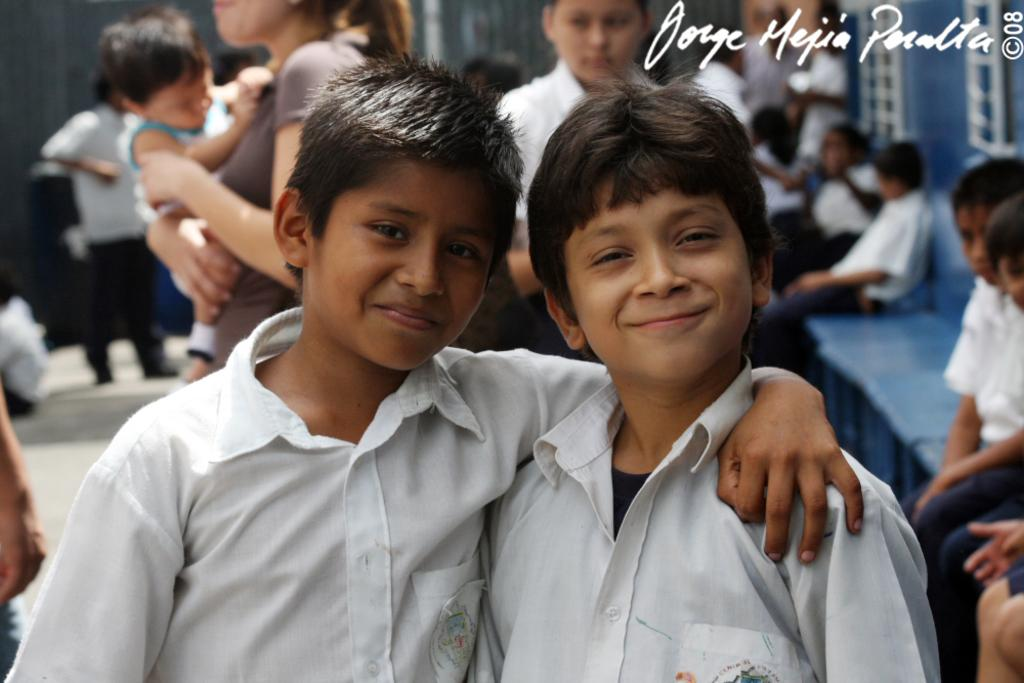How many boys are in the image? There are two boys in the image. What expression do the boys have in the image? The boys are smiling in the image. What can be seen in the background of the image? There is a group of people in the background of the image. What are some of the people in the group doing? Some people in the group are standing, and some are sitting. What type of cannon is being fired by the visitor in the image? There is no cannon or visitor present in the image. What is in the pocket of the boy on the left in the image? The image does not provide information about the contents of the boys' pockets. 